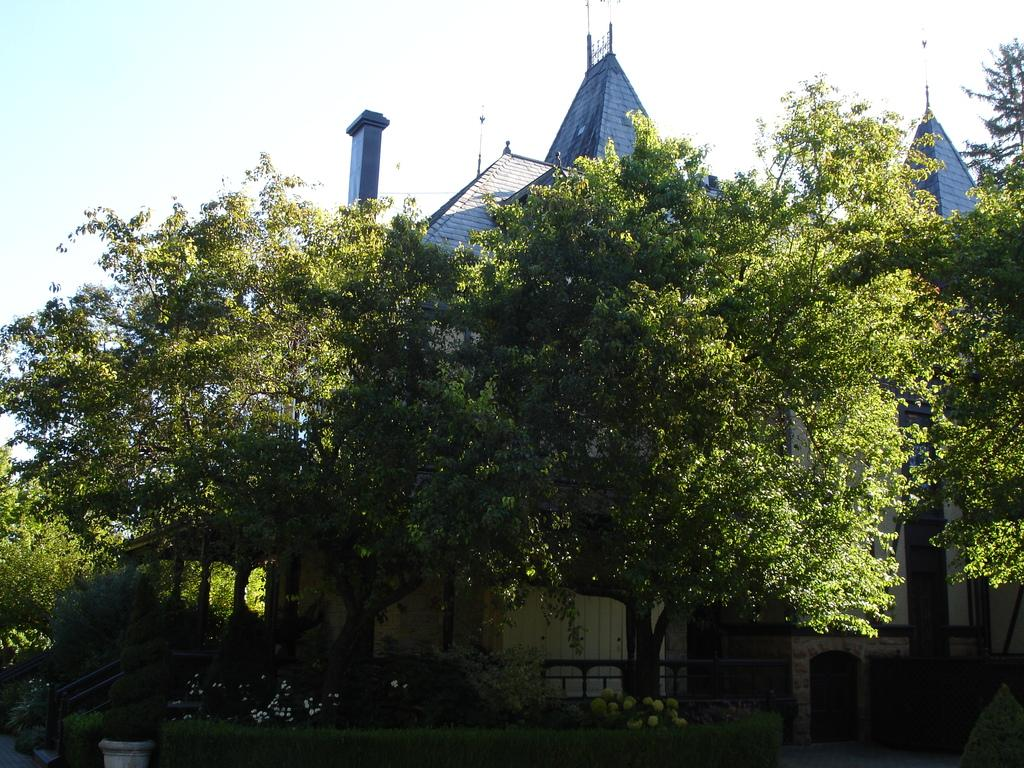What type of vegetation can be seen in the image? There are trees in the image. What is present at the bottom of the image? There is grass and plants at the bottom of the image. What structure can be seen in the background of the image? There is a house in the background of the image. What is visible at the top of the image? The sky is visible at the top of the image. What type of metal is used to construct the joke in the image? There is no joke present in the image, and therefore no metal construction can be associated with it. 